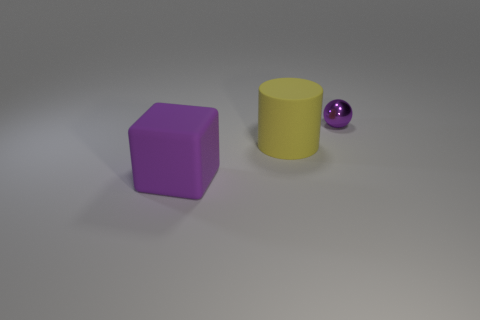The matte thing that is the same color as the ball is what shape?
Your response must be concise. Cube. Is there anything else that has the same material as the yellow cylinder?
Provide a short and direct response. Yes. Does the purple thing in front of the small object have the same material as the purple object right of the big rubber block?
Offer a very short reply. No. What color is the matte thing that is in front of the large object to the right of the purple object that is left of the small thing?
Your answer should be very brief. Purple. What number of other objects are the same shape as the tiny shiny object?
Offer a very short reply. 0. Is the small object the same color as the matte cube?
Provide a succinct answer. Yes. How many objects are green cylinders or purple objects that are left of the purple metal object?
Provide a succinct answer. 1. Is there a metallic ball that has the same size as the yellow rubber cylinder?
Ensure brevity in your answer.  No. Are the purple sphere and the large yellow cylinder made of the same material?
Provide a succinct answer. No. What number of things are either purple things or tiny cyan rubber cylinders?
Ensure brevity in your answer.  2. 